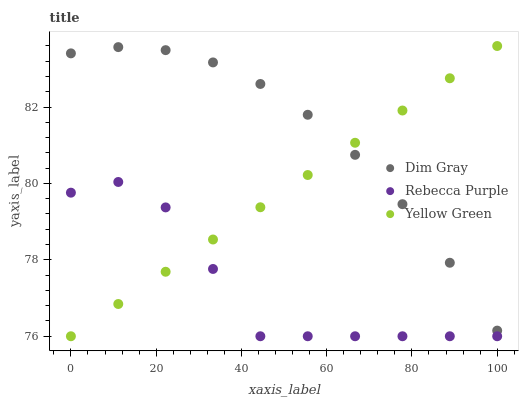Does Rebecca Purple have the minimum area under the curve?
Answer yes or no. Yes. Does Dim Gray have the maximum area under the curve?
Answer yes or no. Yes. Does Yellow Green have the minimum area under the curve?
Answer yes or no. No. Does Yellow Green have the maximum area under the curve?
Answer yes or no. No. Is Yellow Green the smoothest?
Answer yes or no. Yes. Is Rebecca Purple the roughest?
Answer yes or no. Yes. Is Rebecca Purple the smoothest?
Answer yes or no. No. Is Yellow Green the roughest?
Answer yes or no. No. Does Rebecca Purple have the lowest value?
Answer yes or no. Yes. Does Yellow Green have the highest value?
Answer yes or no. Yes. Does Rebecca Purple have the highest value?
Answer yes or no. No. Is Rebecca Purple less than Dim Gray?
Answer yes or no. Yes. Is Dim Gray greater than Rebecca Purple?
Answer yes or no. Yes. Does Yellow Green intersect Rebecca Purple?
Answer yes or no. Yes. Is Yellow Green less than Rebecca Purple?
Answer yes or no. No. Is Yellow Green greater than Rebecca Purple?
Answer yes or no. No. Does Rebecca Purple intersect Dim Gray?
Answer yes or no. No. 